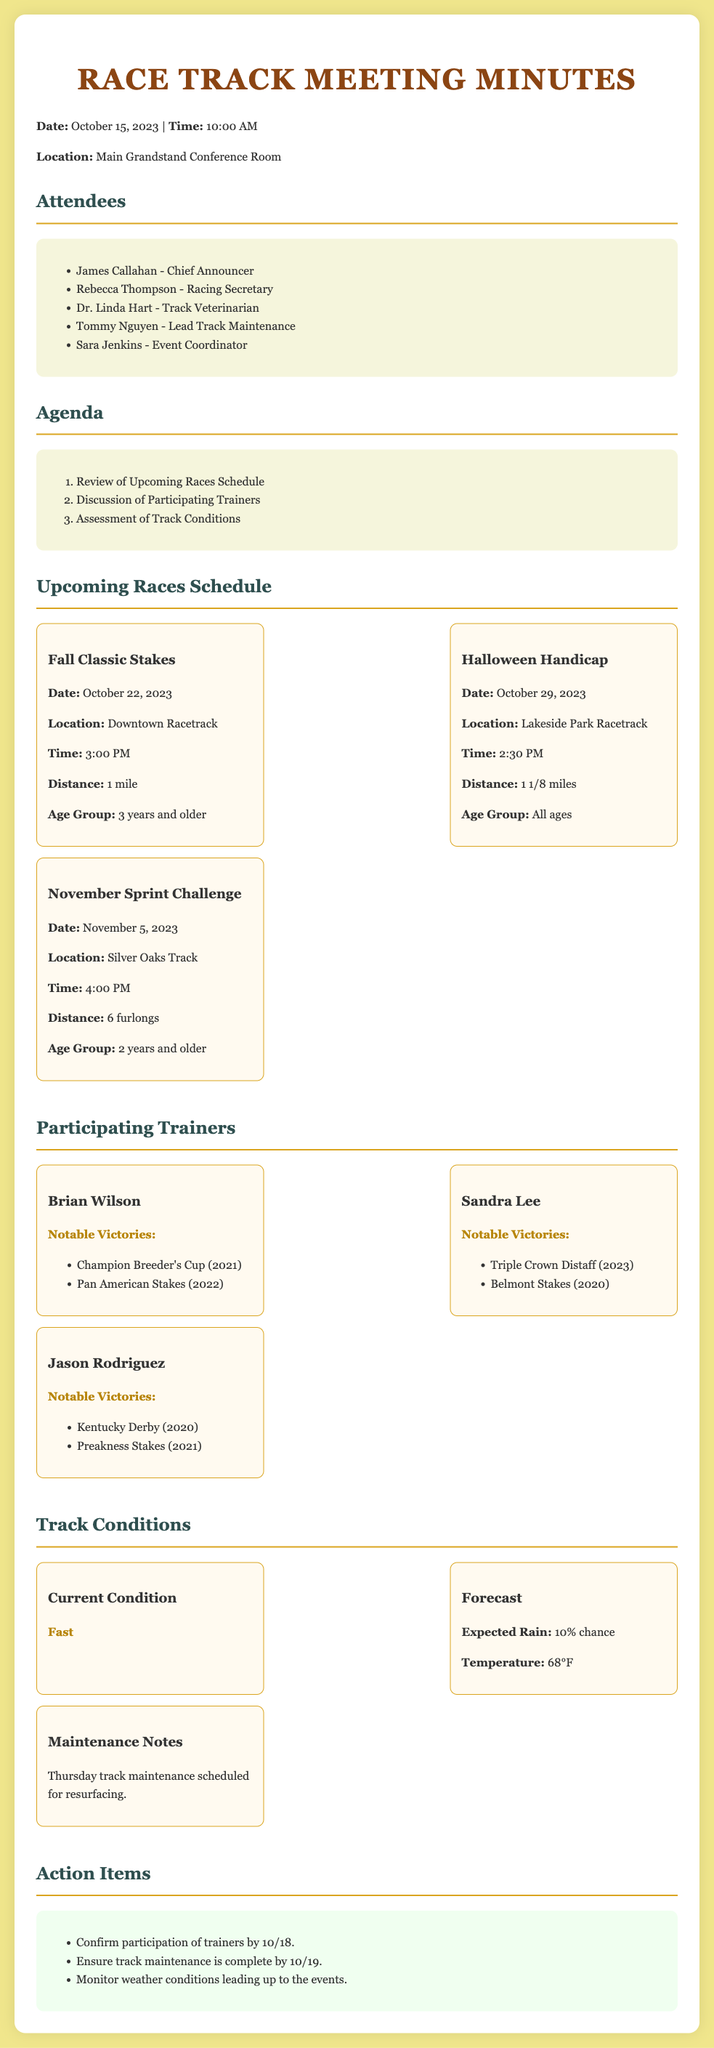What is the date of the Fall Classic Stakes? The date is mentioned in the Upcoming Races Schedule section of the document.
Answer: October 22, 2023 What is the location of the Halloween Handicap? The location is specified in the description of the Halloween Handicap race in the document.
Answer: Lakeside Park Racetrack Who is the trainer known for the Kentucky Derby victory? The document lists trainers along with their notable victories.
Answer: Jason Rodriguez What is the current track condition? The current condition is highlighted in the Track Conditions section of the document.
Answer: Fast When is the track maintenance scheduled for? The maintenance schedule is noted in the Track Conditions section regarding resurfacing.
Answer: Thursday Which age group is eligible for the November Sprint Challenge? The eligible age group is provided in the information about the November Sprint Challenge race.
Answer: 2 years and older What percentage chance of rain is forecasted? The forecast details provide the chance of rain in the Track Conditions section.
Answer: 10% What is the time for the November Sprint Challenge? The time for each race is included in the respective race descriptions.
Answer: 4:00 PM What action item is due by October 19? The action items are listed towards the end of the document, specifying deadlines.
Answer: Ensure track maintenance is complete 